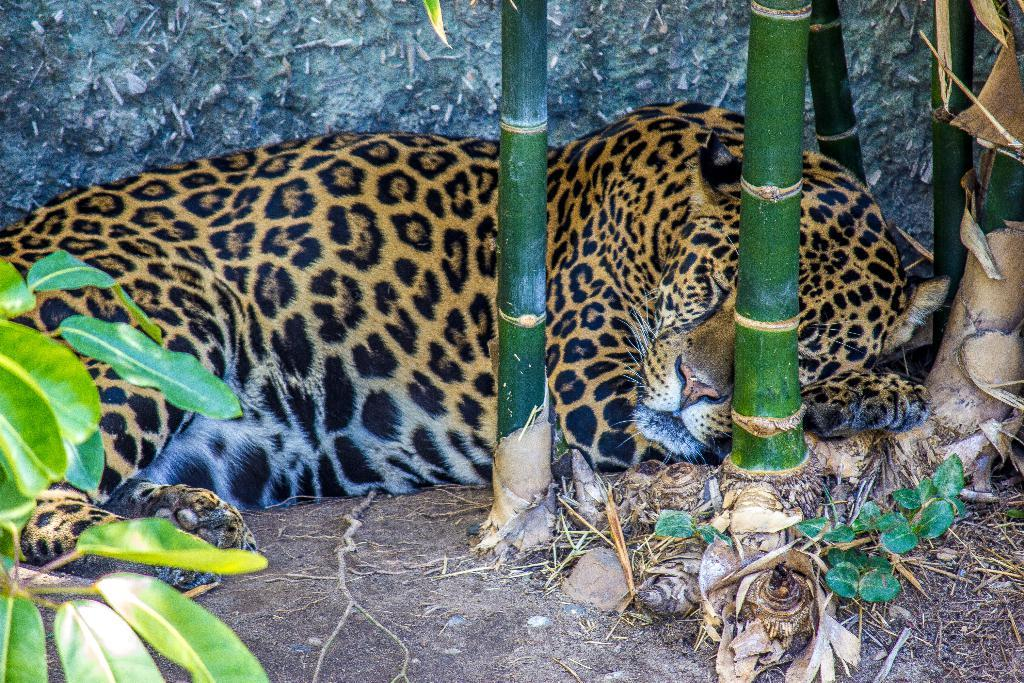What type of animal is in the image? There is a leopard in the image. What is the leopard doing in the image? The leopard is sleeping on the ground. What can be seen in the background of the image? There are plants visible in the image. What is the leopard resting against in the image? There is a wall in the image. What type of education does the leopard have in the image? The image does not provide information about the leopard's education. How does the leopard behave towards other animals in the image? The image does not show the leopard interacting with other animals, so we cannot determine its behavior towards them. 